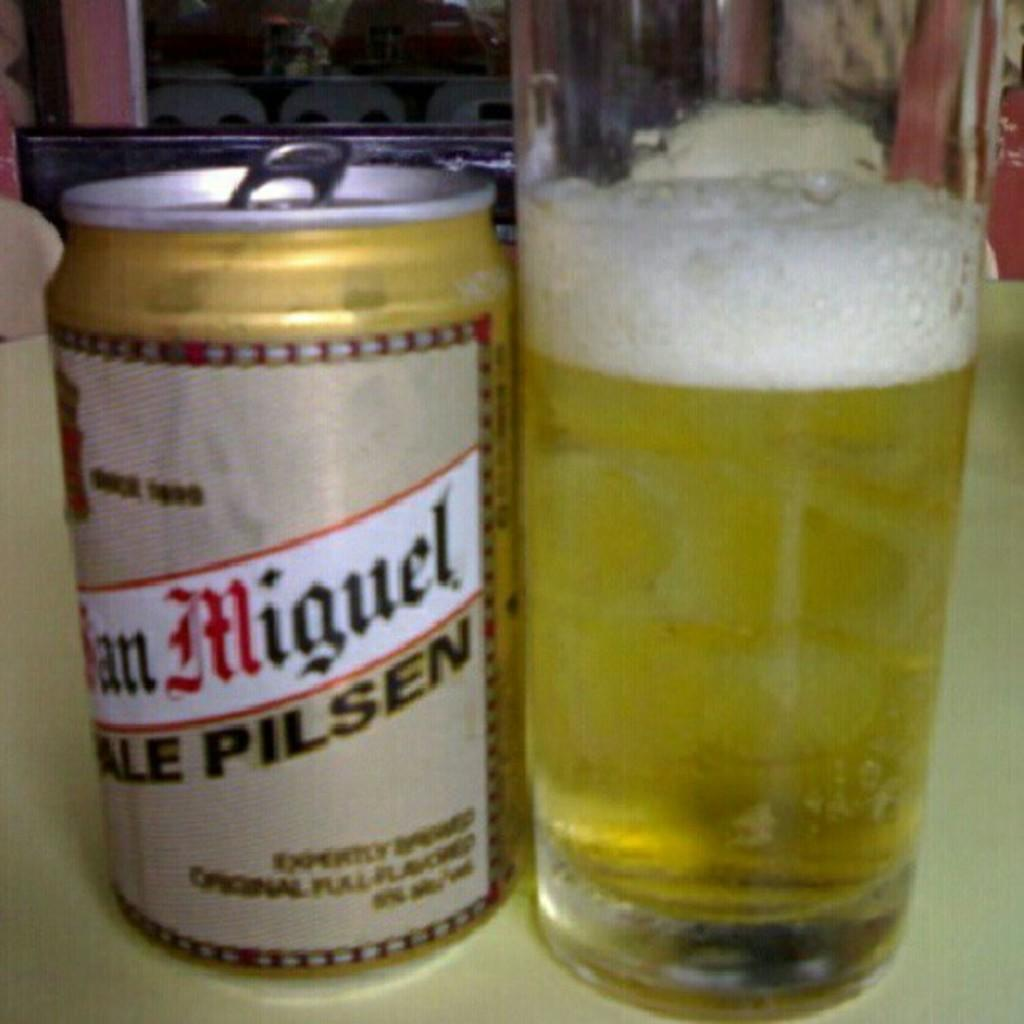<image>
Provide a brief description of the given image. A can of Pale Pilsen beer is next to a full glass. 